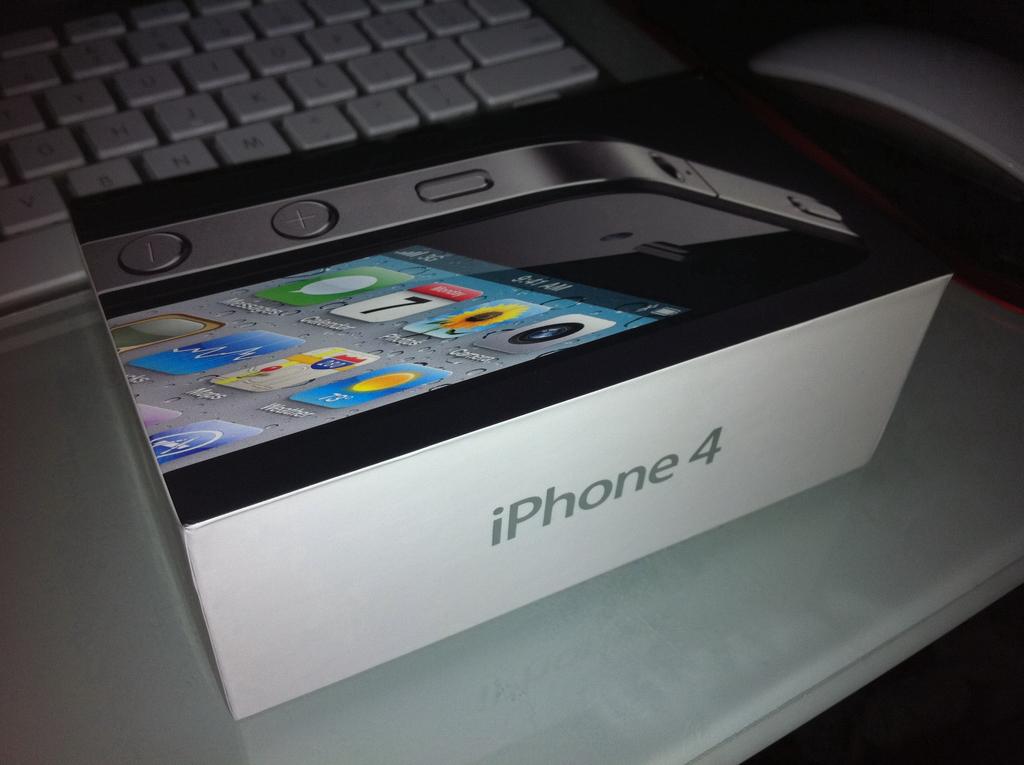What model is the phone?
Your response must be concise. Iphone 4. 